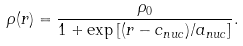<formula> <loc_0><loc_0><loc_500><loc_500>\rho ( r ) = \frac { \rho _ { 0 } } { 1 + \exp { [ ( r - c _ { n u c } ) / a _ { n u c } } ] } .</formula> 